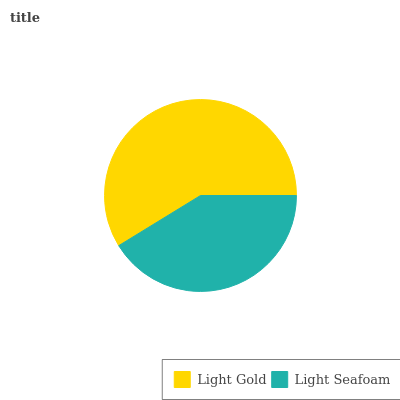Is Light Seafoam the minimum?
Answer yes or no. Yes. Is Light Gold the maximum?
Answer yes or no. Yes. Is Light Seafoam the maximum?
Answer yes or no. No. Is Light Gold greater than Light Seafoam?
Answer yes or no. Yes. Is Light Seafoam less than Light Gold?
Answer yes or no. Yes. Is Light Seafoam greater than Light Gold?
Answer yes or no. No. Is Light Gold less than Light Seafoam?
Answer yes or no. No. Is Light Gold the high median?
Answer yes or no. Yes. Is Light Seafoam the low median?
Answer yes or no. Yes. Is Light Seafoam the high median?
Answer yes or no. No. Is Light Gold the low median?
Answer yes or no. No. 